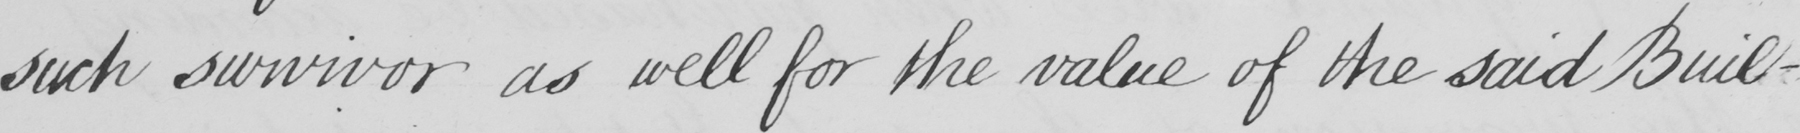Transcribe the text shown in this historical manuscript line. such survivor as well as for the value of the said Buil- 